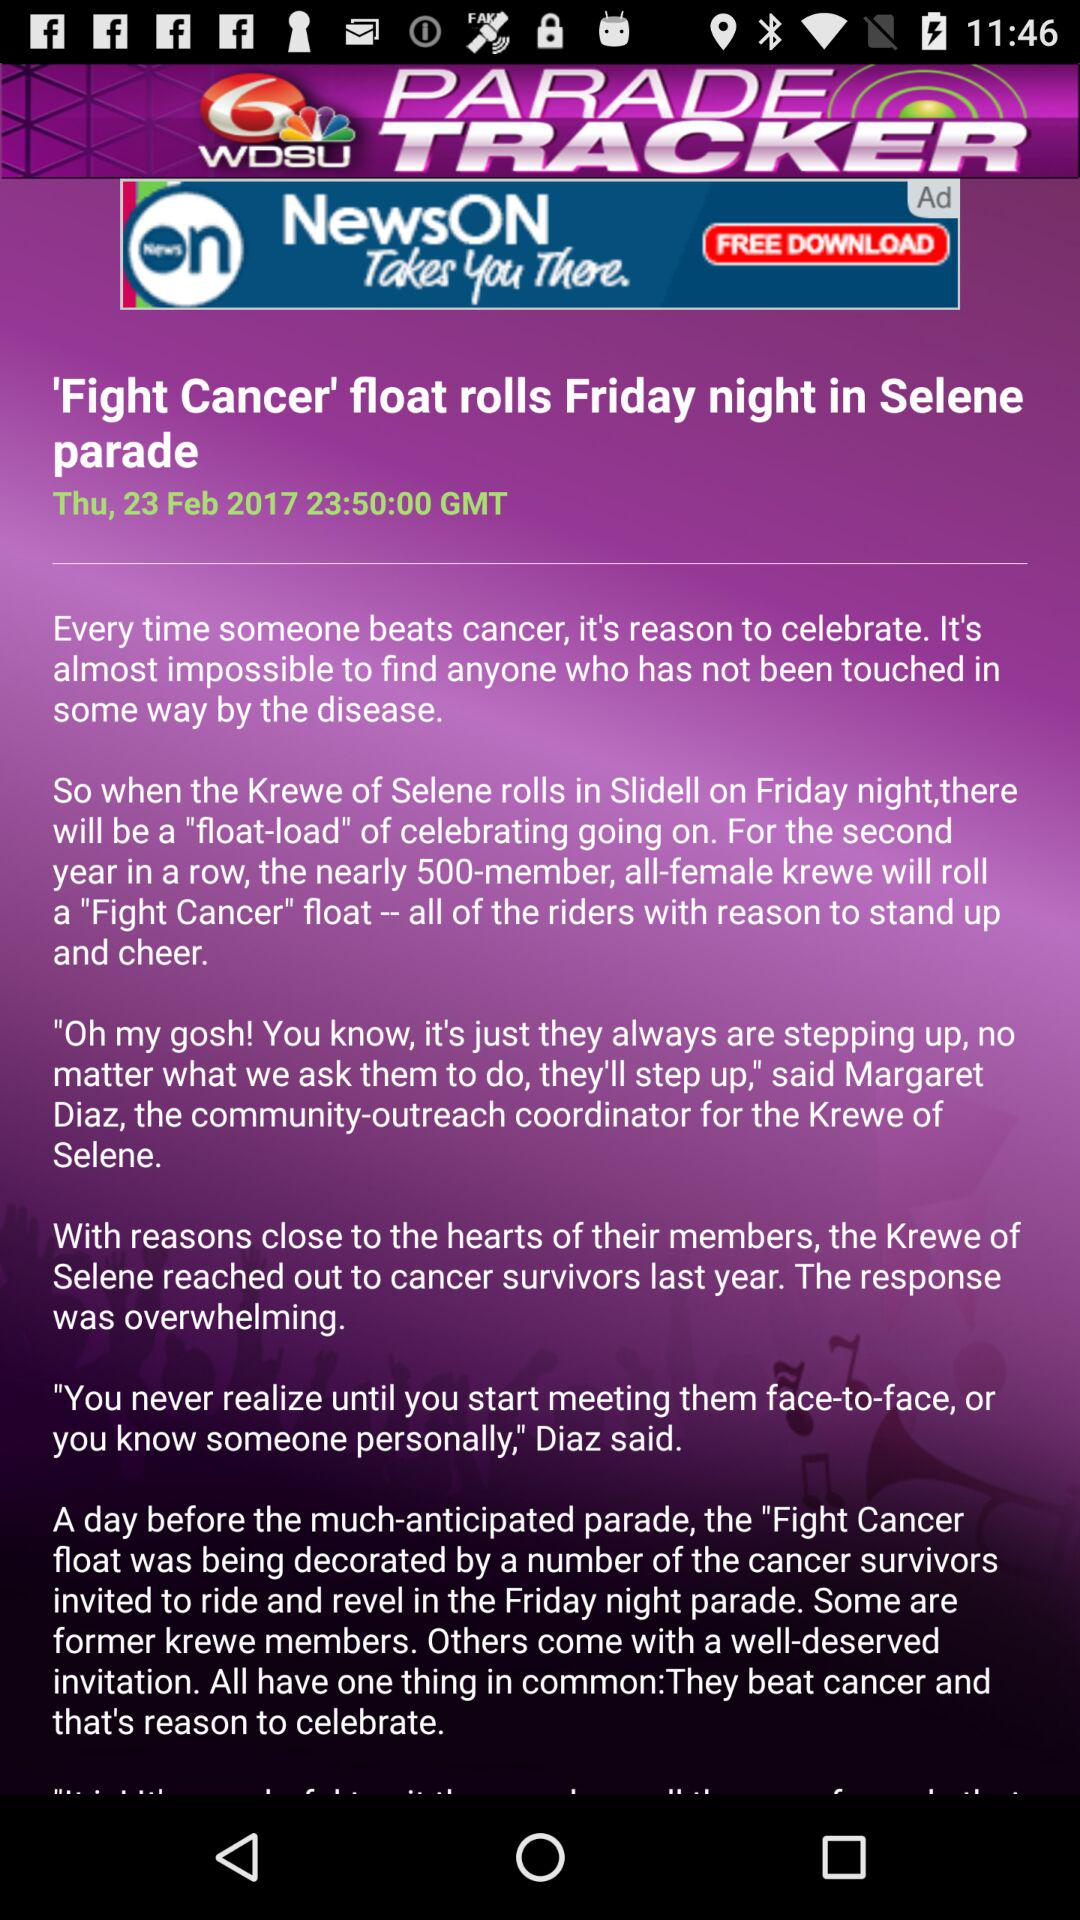What is the headline of the article? The headline of the article is "'Fight Cancer' float rolls Friday night in Selene parade". 